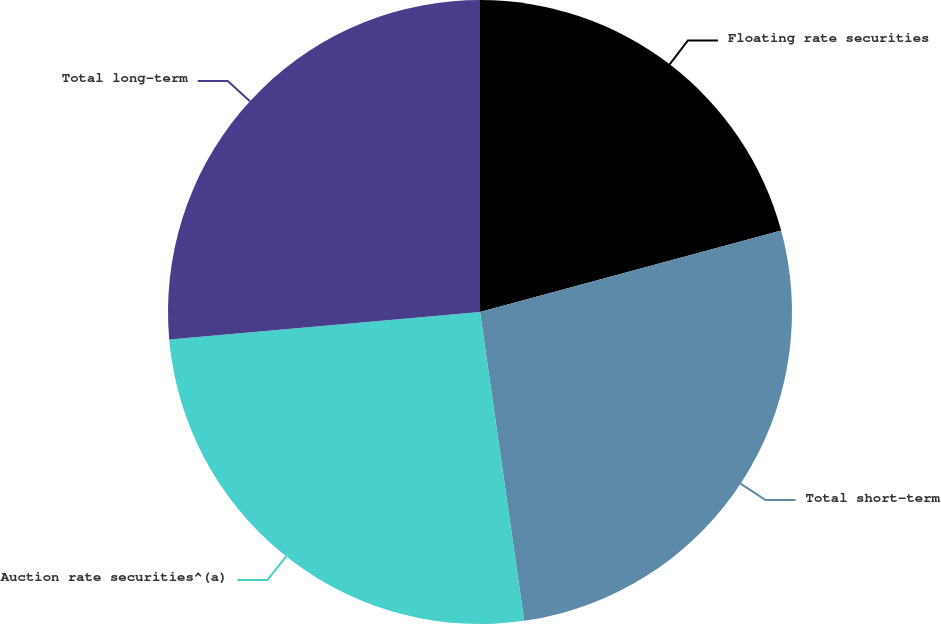<chart> <loc_0><loc_0><loc_500><loc_500><pie_chart><fcel>Floating rate securities<fcel>Total short-term<fcel>Auction rate securities^(a)<fcel>Total long-term<nl><fcel>20.8%<fcel>26.94%<fcel>25.86%<fcel>26.4%<nl></chart> 